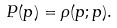Convert formula to latex. <formula><loc_0><loc_0><loc_500><loc_500>P ( p ) = \rho ( p ; p ) .</formula> 